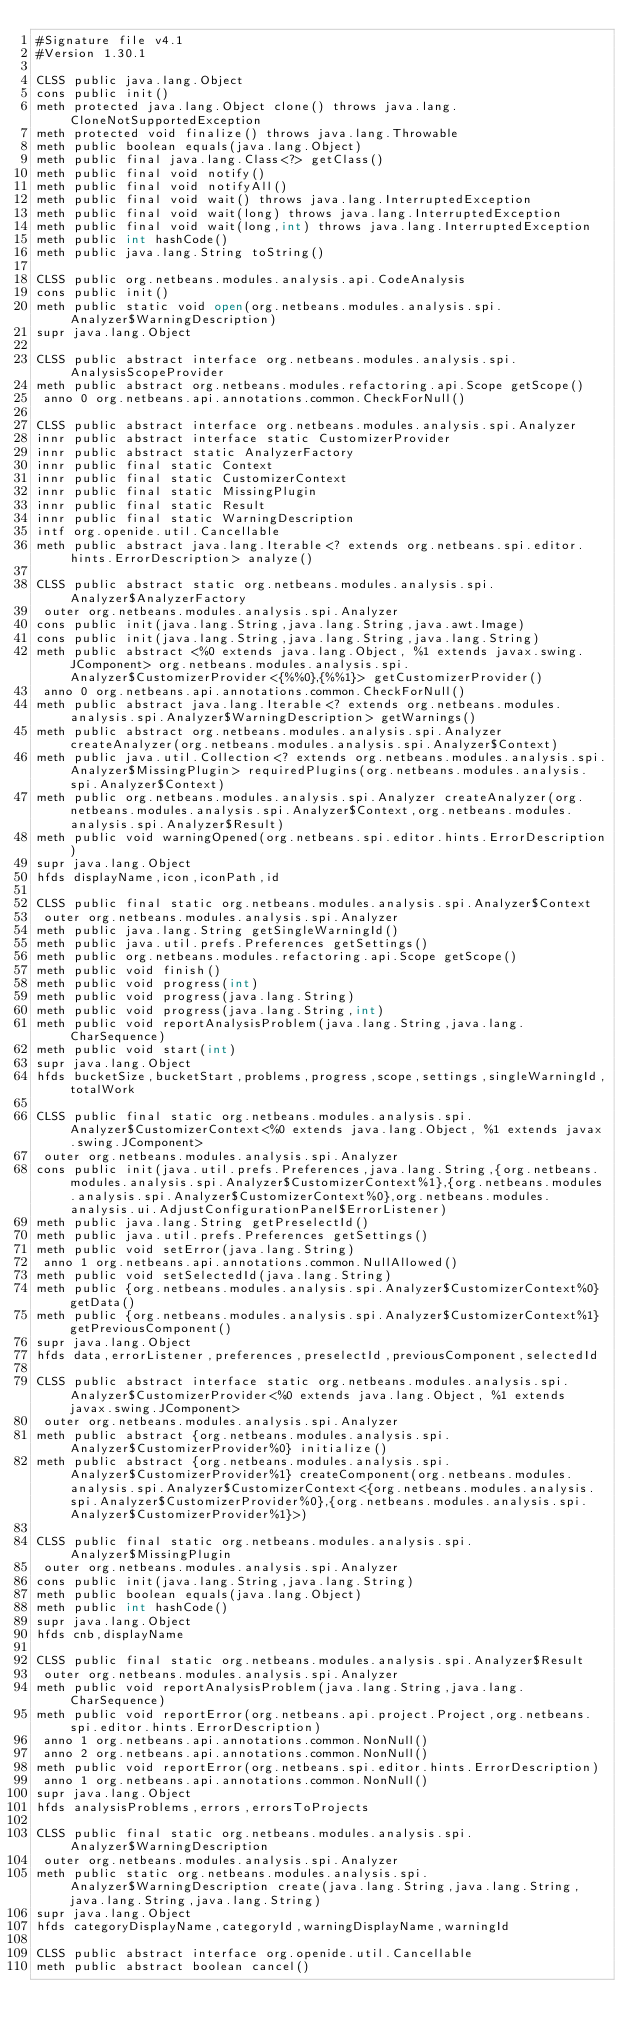Convert code to text. <code><loc_0><loc_0><loc_500><loc_500><_SML_>#Signature file v4.1
#Version 1.30.1

CLSS public java.lang.Object
cons public init()
meth protected java.lang.Object clone() throws java.lang.CloneNotSupportedException
meth protected void finalize() throws java.lang.Throwable
meth public boolean equals(java.lang.Object)
meth public final java.lang.Class<?> getClass()
meth public final void notify()
meth public final void notifyAll()
meth public final void wait() throws java.lang.InterruptedException
meth public final void wait(long) throws java.lang.InterruptedException
meth public final void wait(long,int) throws java.lang.InterruptedException
meth public int hashCode()
meth public java.lang.String toString()

CLSS public org.netbeans.modules.analysis.api.CodeAnalysis
cons public init()
meth public static void open(org.netbeans.modules.analysis.spi.Analyzer$WarningDescription)
supr java.lang.Object

CLSS public abstract interface org.netbeans.modules.analysis.spi.AnalysisScopeProvider
meth public abstract org.netbeans.modules.refactoring.api.Scope getScope()
 anno 0 org.netbeans.api.annotations.common.CheckForNull()

CLSS public abstract interface org.netbeans.modules.analysis.spi.Analyzer
innr public abstract interface static CustomizerProvider
innr public abstract static AnalyzerFactory
innr public final static Context
innr public final static CustomizerContext
innr public final static MissingPlugin
innr public final static Result
innr public final static WarningDescription
intf org.openide.util.Cancellable
meth public abstract java.lang.Iterable<? extends org.netbeans.spi.editor.hints.ErrorDescription> analyze()

CLSS public abstract static org.netbeans.modules.analysis.spi.Analyzer$AnalyzerFactory
 outer org.netbeans.modules.analysis.spi.Analyzer
cons public init(java.lang.String,java.lang.String,java.awt.Image)
cons public init(java.lang.String,java.lang.String,java.lang.String)
meth public abstract <%0 extends java.lang.Object, %1 extends javax.swing.JComponent> org.netbeans.modules.analysis.spi.Analyzer$CustomizerProvider<{%%0},{%%1}> getCustomizerProvider()
 anno 0 org.netbeans.api.annotations.common.CheckForNull()
meth public abstract java.lang.Iterable<? extends org.netbeans.modules.analysis.spi.Analyzer$WarningDescription> getWarnings()
meth public abstract org.netbeans.modules.analysis.spi.Analyzer createAnalyzer(org.netbeans.modules.analysis.spi.Analyzer$Context)
meth public java.util.Collection<? extends org.netbeans.modules.analysis.spi.Analyzer$MissingPlugin> requiredPlugins(org.netbeans.modules.analysis.spi.Analyzer$Context)
meth public org.netbeans.modules.analysis.spi.Analyzer createAnalyzer(org.netbeans.modules.analysis.spi.Analyzer$Context,org.netbeans.modules.analysis.spi.Analyzer$Result)
meth public void warningOpened(org.netbeans.spi.editor.hints.ErrorDescription)
supr java.lang.Object
hfds displayName,icon,iconPath,id

CLSS public final static org.netbeans.modules.analysis.spi.Analyzer$Context
 outer org.netbeans.modules.analysis.spi.Analyzer
meth public java.lang.String getSingleWarningId()
meth public java.util.prefs.Preferences getSettings()
meth public org.netbeans.modules.refactoring.api.Scope getScope()
meth public void finish()
meth public void progress(int)
meth public void progress(java.lang.String)
meth public void progress(java.lang.String,int)
meth public void reportAnalysisProblem(java.lang.String,java.lang.CharSequence)
meth public void start(int)
supr java.lang.Object
hfds bucketSize,bucketStart,problems,progress,scope,settings,singleWarningId,totalWork

CLSS public final static org.netbeans.modules.analysis.spi.Analyzer$CustomizerContext<%0 extends java.lang.Object, %1 extends javax.swing.JComponent>
 outer org.netbeans.modules.analysis.spi.Analyzer
cons public init(java.util.prefs.Preferences,java.lang.String,{org.netbeans.modules.analysis.spi.Analyzer$CustomizerContext%1},{org.netbeans.modules.analysis.spi.Analyzer$CustomizerContext%0},org.netbeans.modules.analysis.ui.AdjustConfigurationPanel$ErrorListener)
meth public java.lang.String getPreselectId()
meth public java.util.prefs.Preferences getSettings()
meth public void setError(java.lang.String)
 anno 1 org.netbeans.api.annotations.common.NullAllowed()
meth public void setSelectedId(java.lang.String)
meth public {org.netbeans.modules.analysis.spi.Analyzer$CustomizerContext%0} getData()
meth public {org.netbeans.modules.analysis.spi.Analyzer$CustomizerContext%1} getPreviousComponent()
supr java.lang.Object
hfds data,errorListener,preferences,preselectId,previousComponent,selectedId

CLSS public abstract interface static org.netbeans.modules.analysis.spi.Analyzer$CustomizerProvider<%0 extends java.lang.Object, %1 extends javax.swing.JComponent>
 outer org.netbeans.modules.analysis.spi.Analyzer
meth public abstract {org.netbeans.modules.analysis.spi.Analyzer$CustomizerProvider%0} initialize()
meth public abstract {org.netbeans.modules.analysis.spi.Analyzer$CustomizerProvider%1} createComponent(org.netbeans.modules.analysis.spi.Analyzer$CustomizerContext<{org.netbeans.modules.analysis.spi.Analyzer$CustomizerProvider%0},{org.netbeans.modules.analysis.spi.Analyzer$CustomizerProvider%1}>)

CLSS public final static org.netbeans.modules.analysis.spi.Analyzer$MissingPlugin
 outer org.netbeans.modules.analysis.spi.Analyzer
cons public init(java.lang.String,java.lang.String)
meth public boolean equals(java.lang.Object)
meth public int hashCode()
supr java.lang.Object
hfds cnb,displayName

CLSS public final static org.netbeans.modules.analysis.spi.Analyzer$Result
 outer org.netbeans.modules.analysis.spi.Analyzer
meth public void reportAnalysisProblem(java.lang.String,java.lang.CharSequence)
meth public void reportError(org.netbeans.api.project.Project,org.netbeans.spi.editor.hints.ErrorDescription)
 anno 1 org.netbeans.api.annotations.common.NonNull()
 anno 2 org.netbeans.api.annotations.common.NonNull()
meth public void reportError(org.netbeans.spi.editor.hints.ErrorDescription)
 anno 1 org.netbeans.api.annotations.common.NonNull()
supr java.lang.Object
hfds analysisProblems,errors,errorsToProjects

CLSS public final static org.netbeans.modules.analysis.spi.Analyzer$WarningDescription
 outer org.netbeans.modules.analysis.spi.Analyzer
meth public static org.netbeans.modules.analysis.spi.Analyzer$WarningDescription create(java.lang.String,java.lang.String,java.lang.String,java.lang.String)
supr java.lang.Object
hfds categoryDisplayName,categoryId,warningDisplayName,warningId

CLSS public abstract interface org.openide.util.Cancellable
meth public abstract boolean cancel()

</code> 